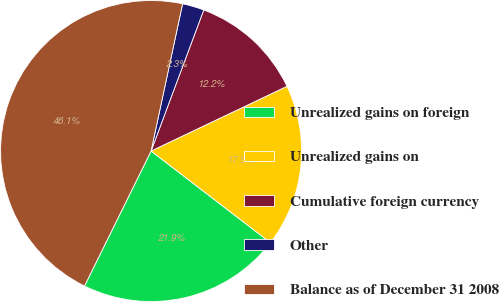Convert chart to OTSL. <chart><loc_0><loc_0><loc_500><loc_500><pie_chart><fcel>Unrealized gains on foreign<fcel>Unrealized gains on<fcel>Cumulative foreign currency<fcel>Other<fcel>Balance as of December 31 2008<nl><fcel>21.87%<fcel>17.49%<fcel>12.24%<fcel>2.33%<fcel>46.06%<nl></chart> 